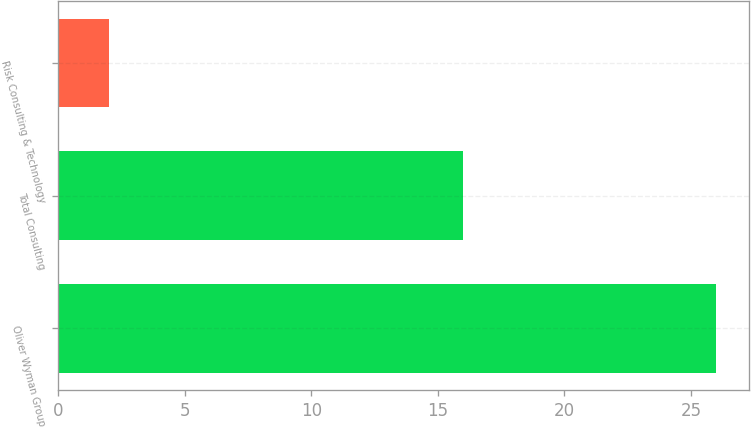Convert chart to OTSL. <chart><loc_0><loc_0><loc_500><loc_500><bar_chart><fcel>Oliver Wyman Group<fcel>Total Consulting<fcel>Risk Consulting & Technology<nl><fcel>26<fcel>16<fcel>2<nl></chart> 